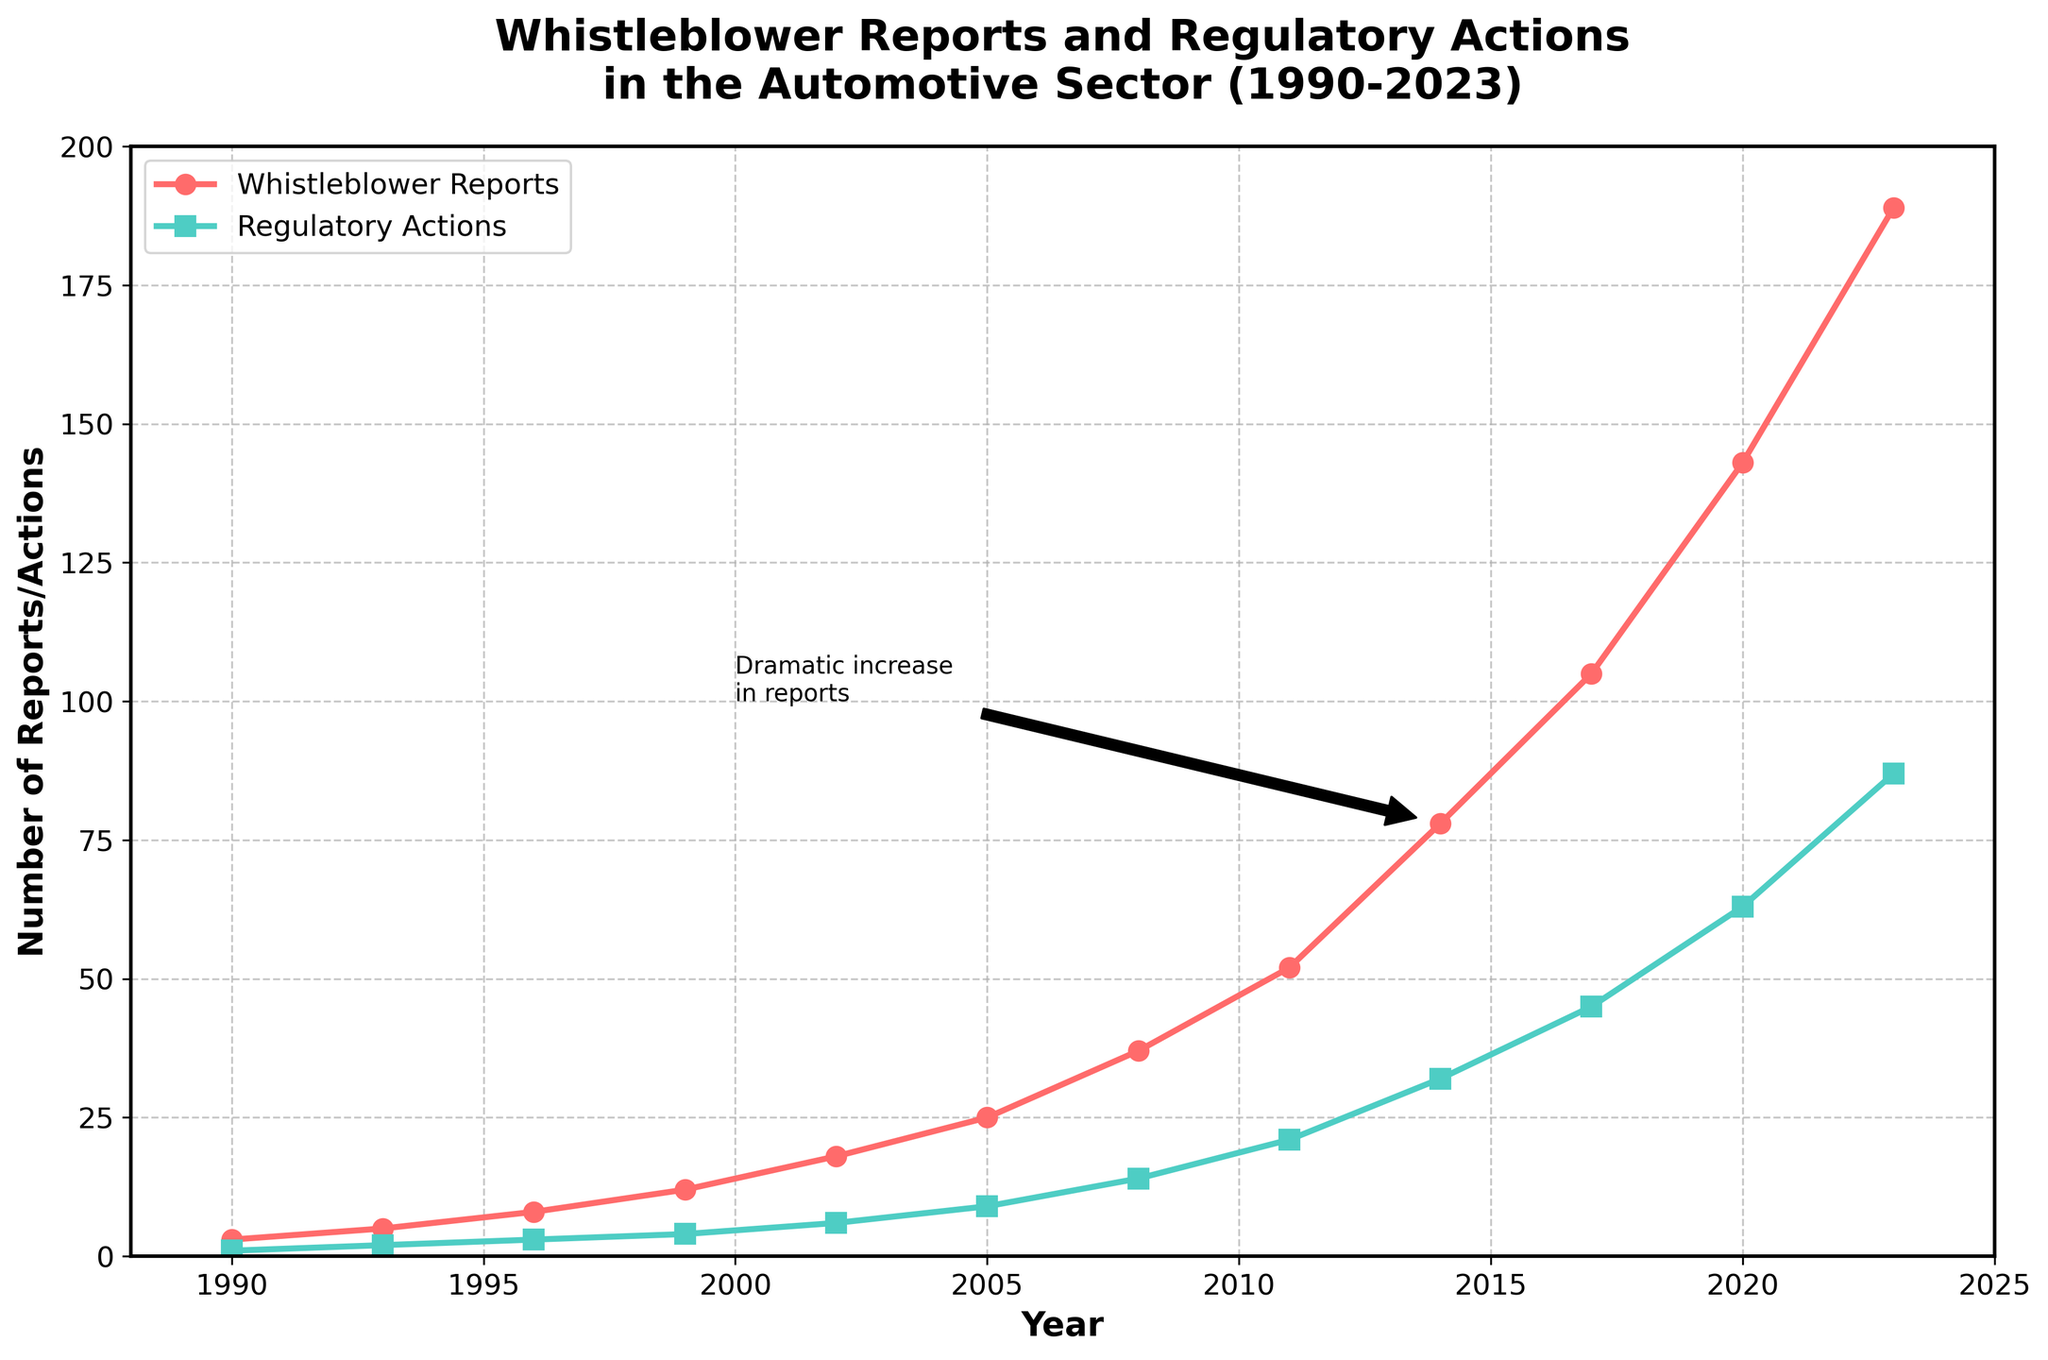When did the number of whistleblower reports first exceed 50? The exact visual point when the number of whistleblower reports exceeds 50 is marked by the year 2011 on the x-axis, where the line for whistleblower reports is above the 50 mark.
Answer: 2011 What is the difference between the number of whistleblower reports and regulatory actions in 2023? For 2023, the number of whistleblower reports is 189 and the number of regulatory actions is 87. The difference is 189 - 87, which equals 102.
Answer: 102 What is the trend observed for whistleblower reports between 1990 and 2023? The plot shows an increasing trend, with the number of whistleblower reports growing steadily from 3 in 1990 to 189 in 2023, indicating significant growth over the 30-year period.
Answer: Increasing How does the trend of regulatory actions compare to the trend of whistleblower reports? Both the whistleblower reports and regulatory actions show an increasing trend over the years, with regulatory actions lagging behind whistleblower reports but following a similar upward trajectory.
Answer: Similar upward trend By how much did the number of regulatory actions increase from 1990 to 2023? The number of regulatory actions in 1990 was 1, and in 2023 it was 87. The increase is 87 - 1, which equals 86.
Answer: 86 During which period did the number of whistleblower reports show the most rapid increase? The figure shows a dramatic increase in whistleblower reports starting around 2011 and significantly accelerating through 2023. This period has the steepest slope indicating the most rapid increase.
Answer: 2011-2023 Which year marks the midpoint in the timeline provided, and what were the values for whistleblower reports and regulatory actions in that year? The timeline spans from 1990 to 2023, with the midpoint around 2007. In 2008 (closest data point), there were 37 whistleblower reports and 14 regulatory actions.
Answer: 2008; 37 reports, 14 actions Which data series (whistleblower reports or regulatory actions) had the highest average annual increase? To compare, calculate the total increase for both from 1990 to 2023 and divide by the number of years. Whistleblower reports increase: 189 - 3 = 186 over 33 years (about 5.64 per year). Regulatory actions increase: 87 - 1 = 86 over 33 years (about 2.61 per year). Whistleblower reports had the higher average annual increase.
Answer: Whistleblower reports Are the increments in whistleblower reports between each time period constant or variable? Observing the line plot for whistleblower reports, the increments are variable, with the increases becoming larger over time, especially after 2011, indicating non-constant increments.
Answer: Variable What is the ratio between the number of whistleblower reports and regulatory actions in 2020? In 2020, there were 143 whistleblower reports and 63 regulatory actions. The ratio is 143:63, which simplifies approximately to 2.27:1.
Answer: 2.27:1 